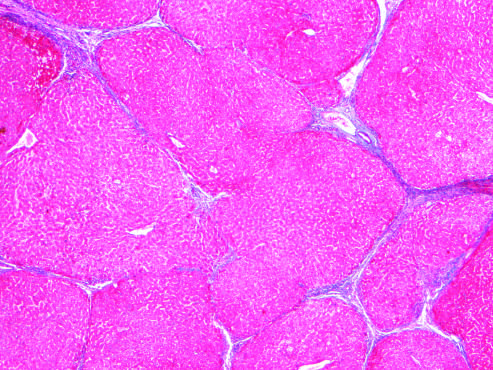when are most scars gone masson trichrome stain?
Answer the question using a single word or phrase. After abstinence 